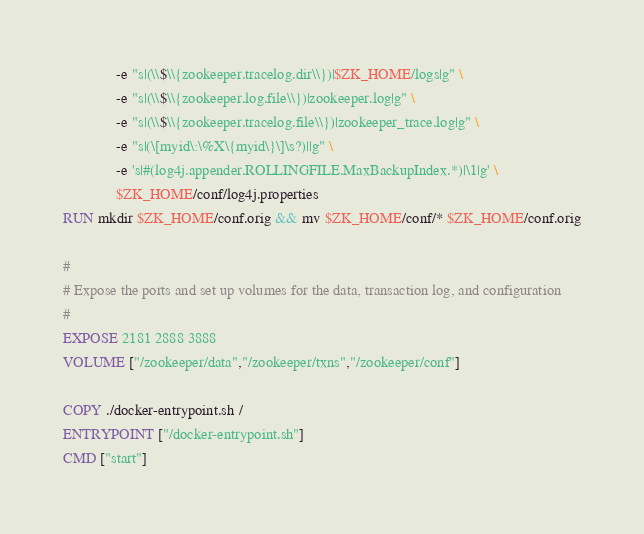<code> <loc_0><loc_0><loc_500><loc_500><_Dockerfile_>              -e "s|(\\$\\{zookeeper.tracelog.dir\\})|$ZK_HOME/logs|g" \
              -e "s|(\\$\\{zookeeper.log.file\\})|zookeeper.log|g" \
              -e "s|(\\$\\{zookeeper.tracelog.file\\})|zookeeper_trace.log|g" \
              -e "s|(\[myid\:\%X\{myid\}\]\s?)||g" \
              -e 's|#(log4j.appender.ROLLINGFILE.MaxBackupIndex.*)|\1|g' \
              $ZK_HOME/conf/log4j.properties
RUN mkdir $ZK_HOME/conf.orig && mv $ZK_HOME/conf/* $ZK_HOME/conf.orig

#
# Expose the ports and set up volumes for the data, transaction log, and configuration
#
EXPOSE 2181 2888 3888
VOLUME ["/zookeeper/data","/zookeeper/txns","/zookeeper/conf"]

COPY ./docker-entrypoint.sh /
ENTRYPOINT ["/docker-entrypoint.sh"]
CMD ["start"]
</code> 